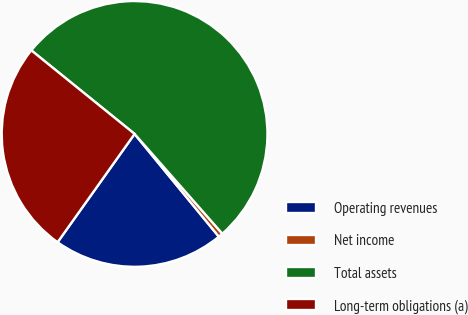Convert chart. <chart><loc_0><loc_0><loc_500><loc_500><pie_chart><fcel>Operating revenues<fcel>Net income<fcel>Total assets<fcel>Long-term obligations (a)<nl><fcel>20.77%<fcel>0.55%<fcel>52.69%<fcel>25.99%<nl></chart> 